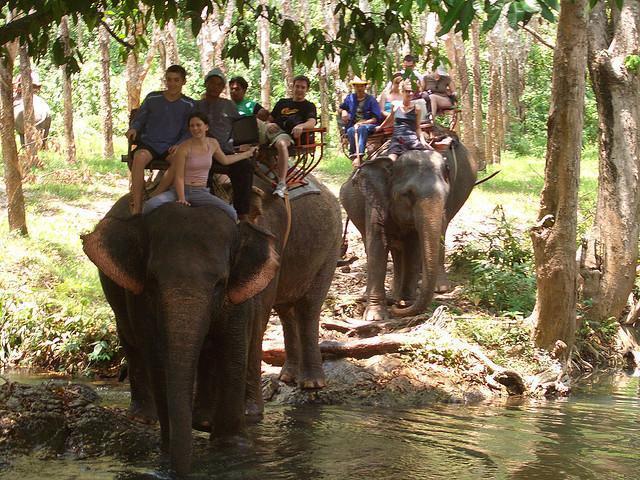How many elephants are in the water?
Give a very brief answer. 1. How many people are visible?
Give a very brief answer. 6. How many elephants can be seen?
Give a very brief answer. 2. 